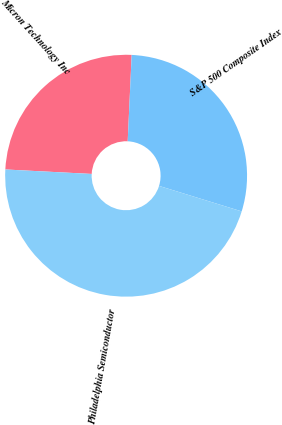Convert chart to OTSL. <chart><loc_0><loc_0><loc_500><loc_500><pie_chart><fcel>Micron Technology Inc<fcel>S&P 500 Composite Index<fcel>Philadelphia Semiconductor<nl><fcel>24.91%<fcel>29.03%<fcel>46.06%<nl></chart> 